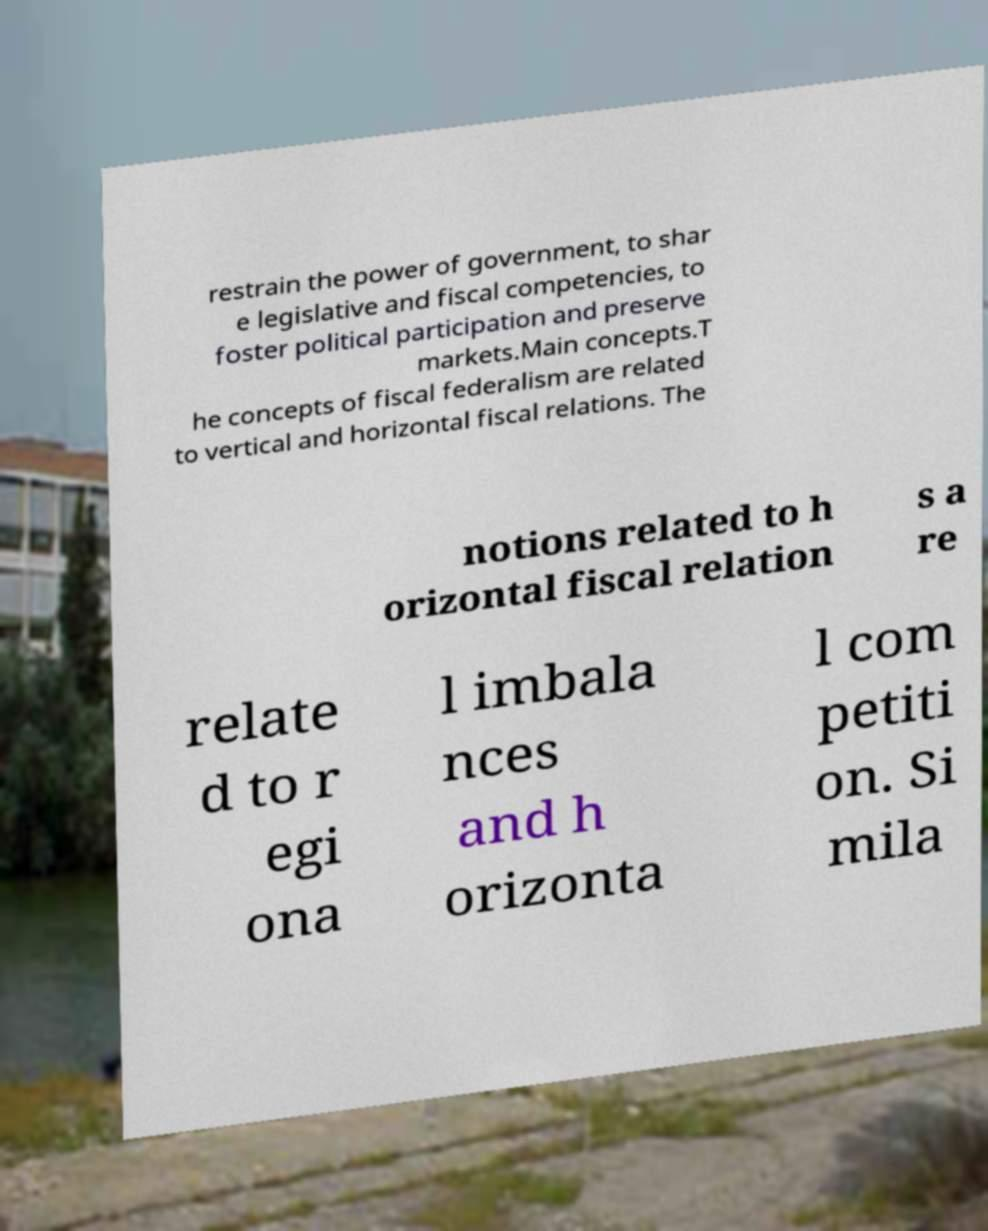For documentation purposes, I need the text within this image transcribed. Could you provide that? restrain the power of government, to shar e legislative and fiscal competencies, to foster political participation and preserve markets.Main concepts.T he concepts of fiscal federalism are related to vertical and horizontal fiscal relations. The notions related to h orizontal fiscal relation s a re relate d to r egi ona l imbala nces and h orizonta l com petiti on. Si mila 